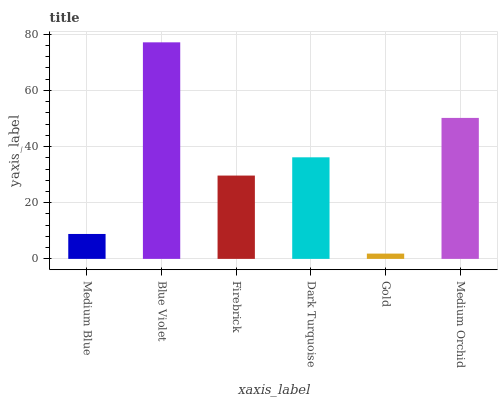Is Gold the minimum?
Answer yes or no. Yes. Is Blue Violet the maximum?
Answer yes or no. Yes. Is Firebrick the minimum?
Answer yes or no. No. Is Firebrick the maximum?
Answer yes or no. No. Is Blue Violet greater than Firebrick?
Answer yes or no. Yes. Is Firebrick less than Blue Violet?
Answer yes or no. Yes. Is Firebrick greater than Blue Violet?
Answer yes or no. No. Is Blue Violet less than Firebrick?
Answer yes or no. No. Is Dark Turquoise the high median?
Answer yes or no. Yes. Is Firebrick the low median?
Answer yes or no. Yes. Is Medium Blue the high median?
Answer yes or no. No. Is Blue Violet the low median?
Answer yes or no. No. 